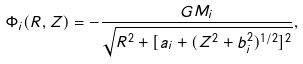<formula> <loc_0><loc_0><loc_500><loc_500>\Phi _ { i } ( R , Z ) = - \frac { G M _ { i } } { \sqrt { R ^ { 2 } + [ a _ { i } + ( Z ^ { 2 } + b _ { i } ^ { 2 } ) ^ { 1 / 2 } ] ^ { 2 } } } ,</formula> 